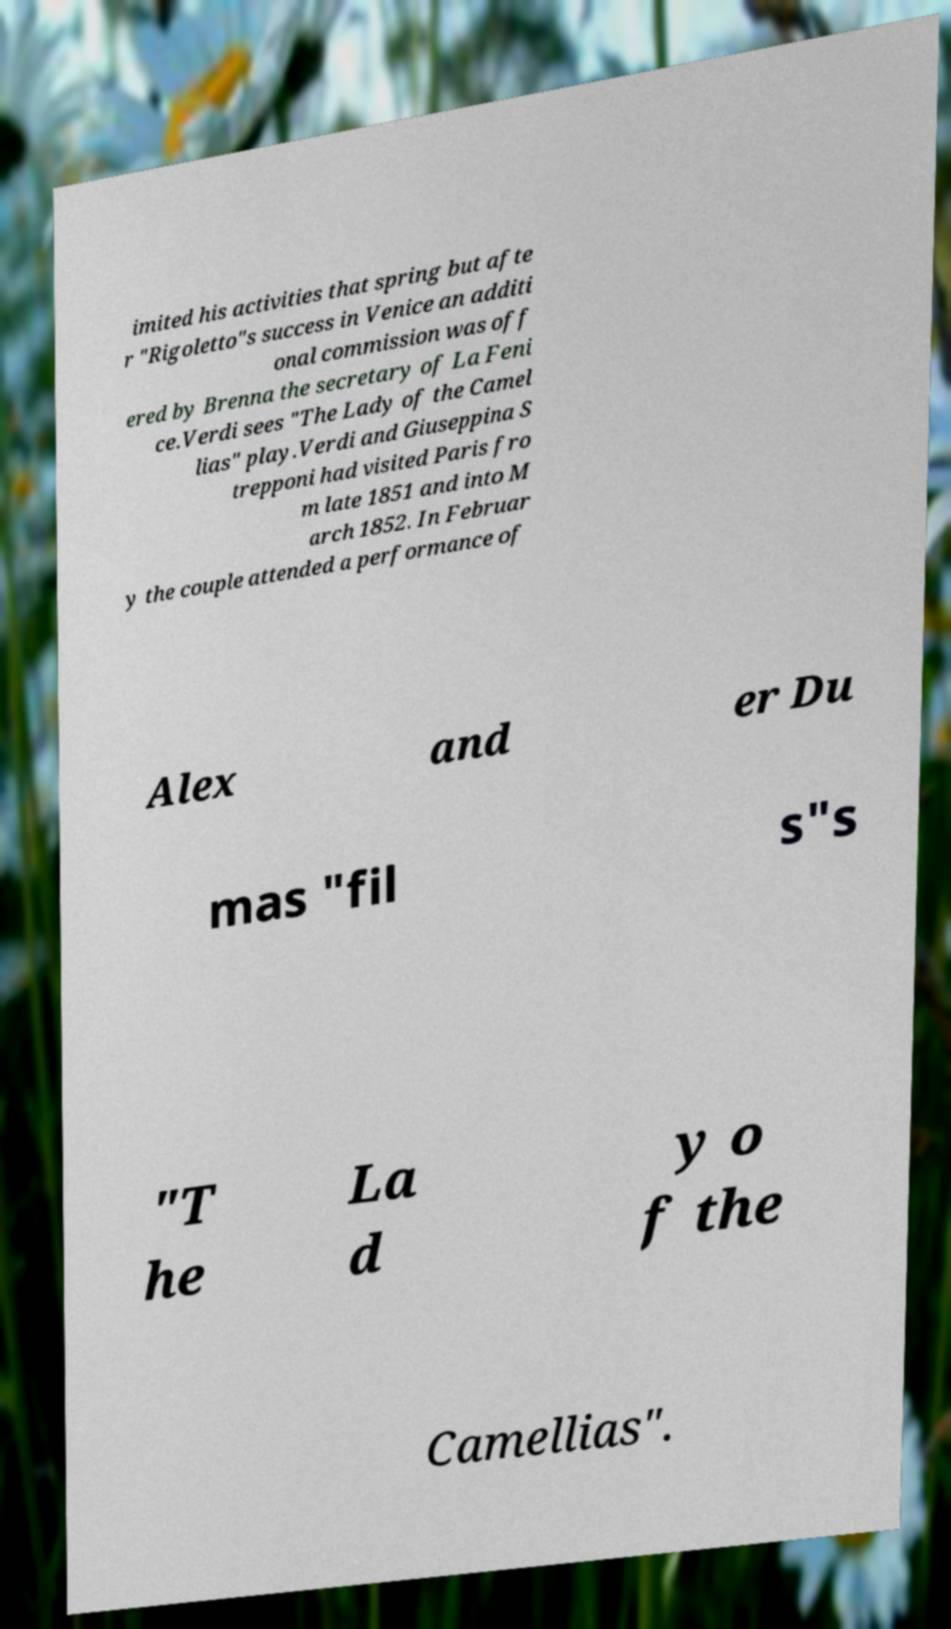There's text embedded in this image that I need extracted. Can you transcribe it verbatim? imited his activities that spring but afte r "Rigoletto"s success in Venice an additi onal commission was off ered by Brenna the secretary of La Feni ce.Verdi sees "The Lady of the Camel lias" play.Verdi and Giuseppina S trepponi had visited Paris fro m late 1851 and into M arch 1852. In Februar y the couple attended a performance of Alex and er Du mas "fil s"s "T he La d y o f the Camellias". 